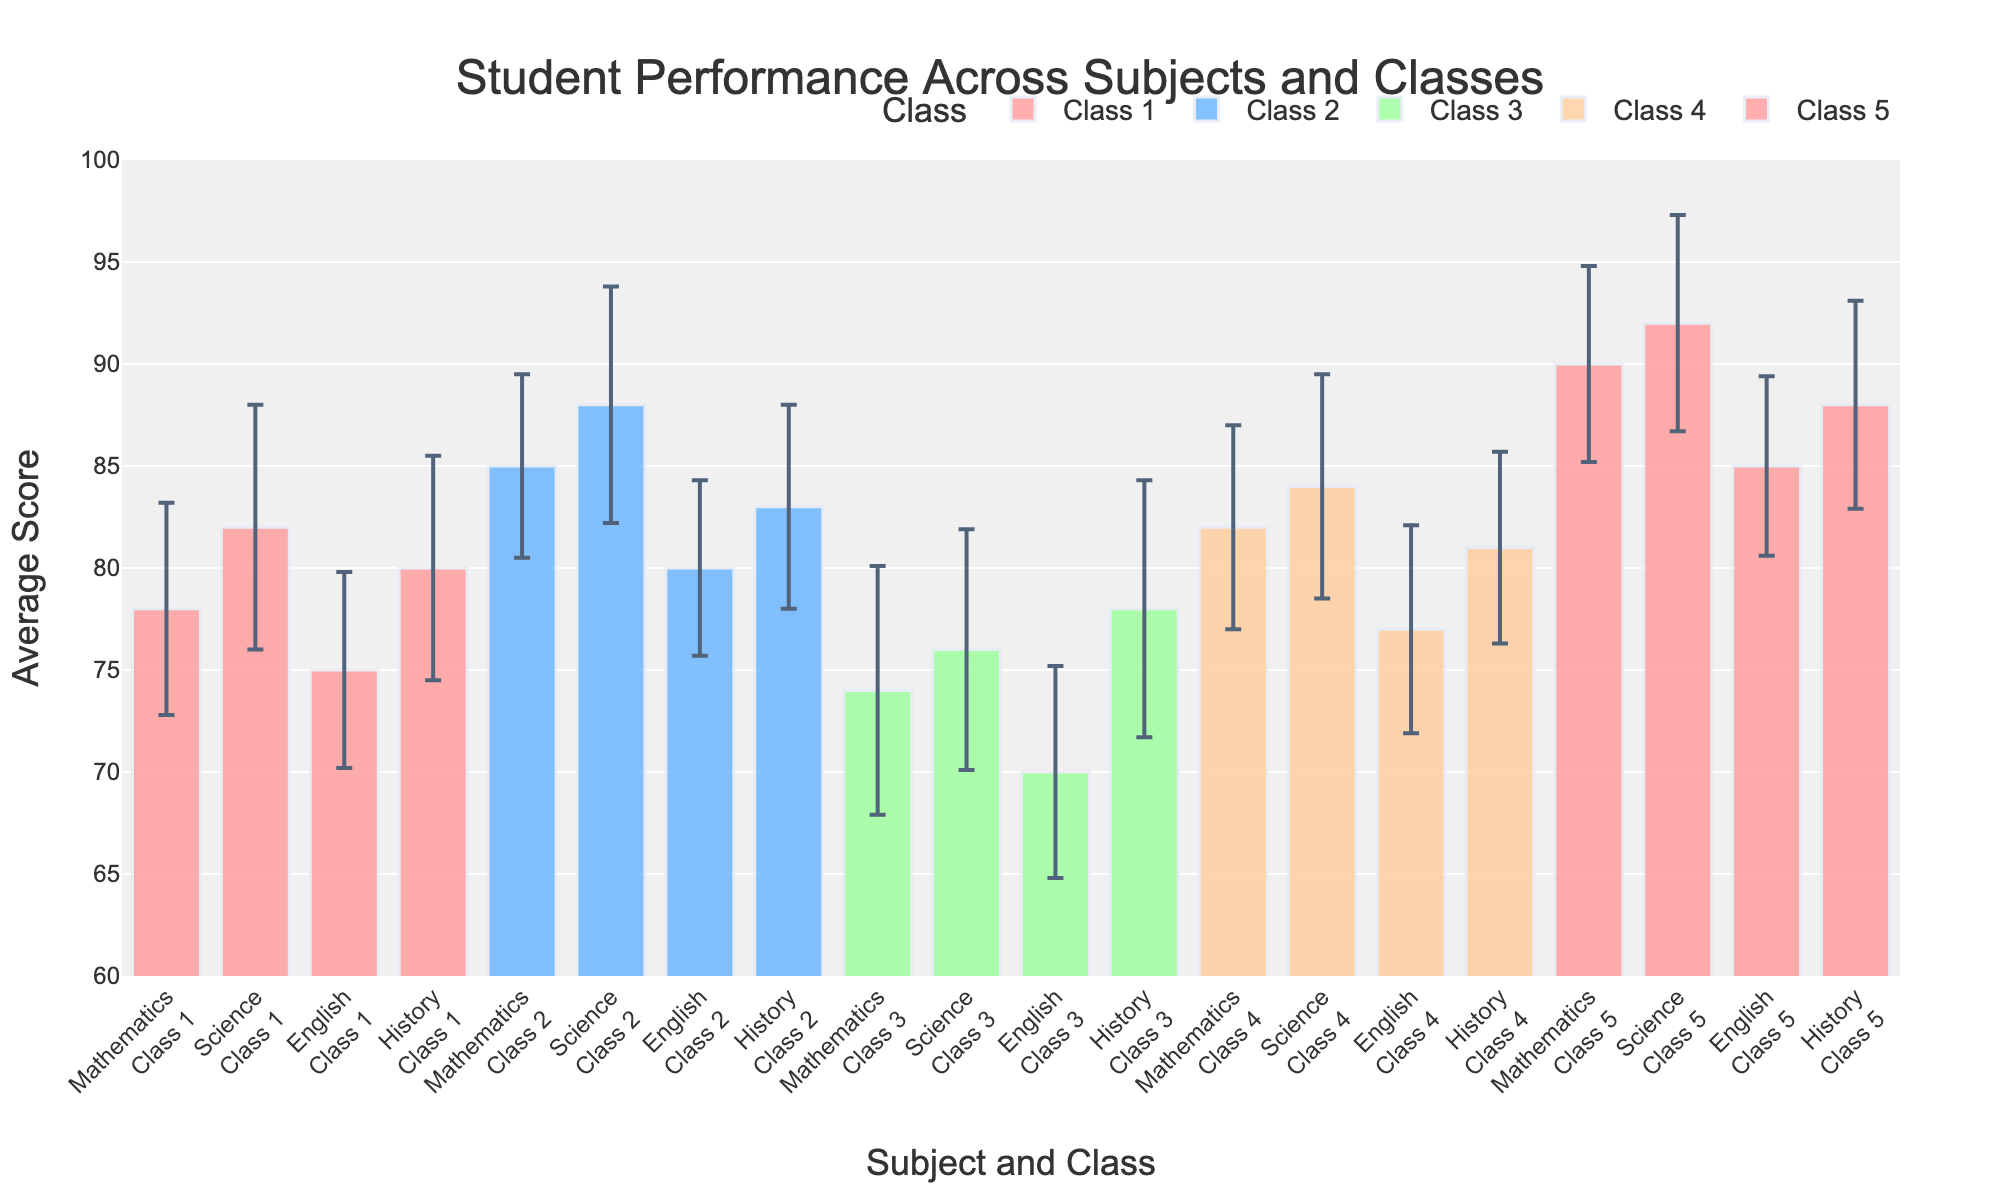What is the title of the figure? The title of the figure is usually located at the top of the plot. In this case, it reads "Student Performance Across Subjects and Classes".
Answer: Student Performance Across Subjects and Classes Which class has the highest average score in Mathematics? Look for the bar representing Mathematics and compare the heights of each class's bar. Class 5 has the highest bar for Mathematics.
Answer: Class 5 How many subjects are displayed in the figure? The x-axis labels show repeated subject names for each class. Counting any one group's subjects, we find Mathematics, Science, English, and History, making a total of 4 subjects represented.
Answer: 4 Which class shows the greatest variability in their score for English? The error bars indicate variability. For English, compare the length of error bars across classes. Class 3 has the longest error bar, indicating the greatest variability.
Answer: Class 3 What is the average score for History in Class 4? Locate the bar for History under Class 4 and check its height. The average score for History in Class 4 is listed as 81.
Answer: 81 Which subject has the lowest average score across all classes? Compare the bars across all subjects and classes. English in Class 3 has the shortest bar, thus the lowest average score, which is 70.
Answer: English in Class 3 How does the average score in Science for Class 2 compare to that of Class 4? Find the bars for Science in Class 2 and Class 4. Class 2 has an average of 88, while Class 4 has an average of 84. So, Class 2 scores higher.
Answer: Class 2 scores higher What is the difference in average scores for Mathematics between Class 1 and Class 3? Look at the heights of Mathematics bars for Class 1 and Class 3. Class 1 has an average score of 78, while Class 3 has 74. The difference is 78 - 74.
Answer: 4 What is the trend in the average scores for Science across Classes 1 through 5? Observe the bars for Science across the sequence of classes. The scores are 82, 88, 76, 84, and 92, showing a general increasing trend with some variability.
Answer: Increasing trend with variability Which class has the most consistent average scores across all subjects, indicated by the shortest error bars overall? Examine the error bars for each class. Class 2 consistently has shorter error bars across subjects, indicating less variability.
Answer: Class 2 